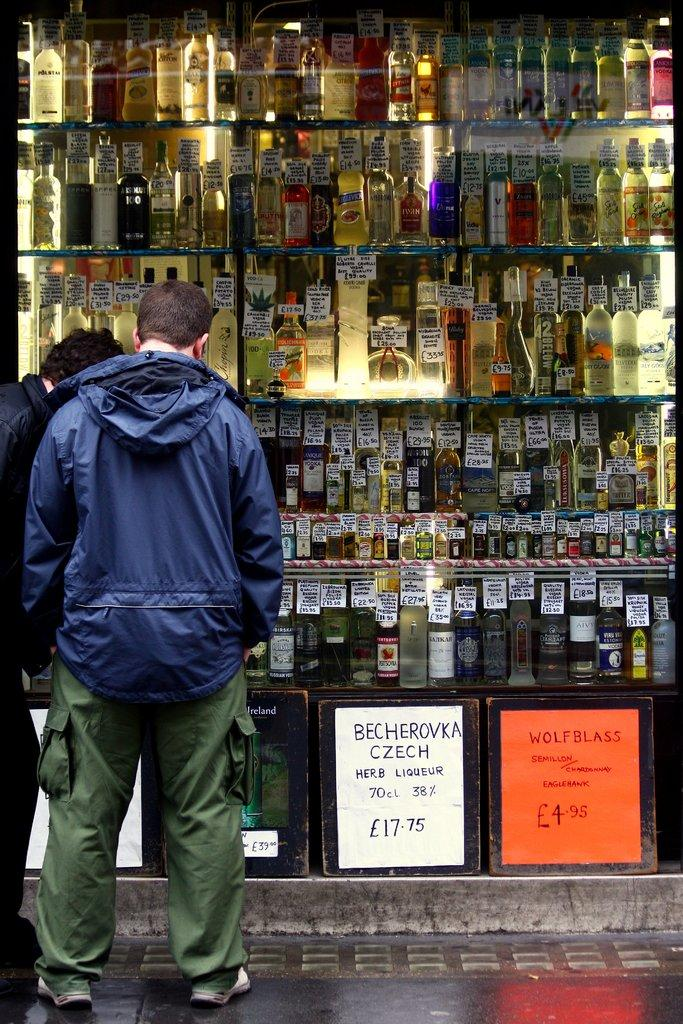How many people are present in the image? There are two men standing in the image. What objects can be seen in the image besides the men? There are bottles and boards with writing in the image. Can you describe the clothing of one of the men? One person is wearing a jacket, pants, and shoes. Is there a machine that produces horn sounds in the image? There is no machine or horn sounds present in the image. Can you see any quicksand in the image? There is no quicksand visible in the image. 